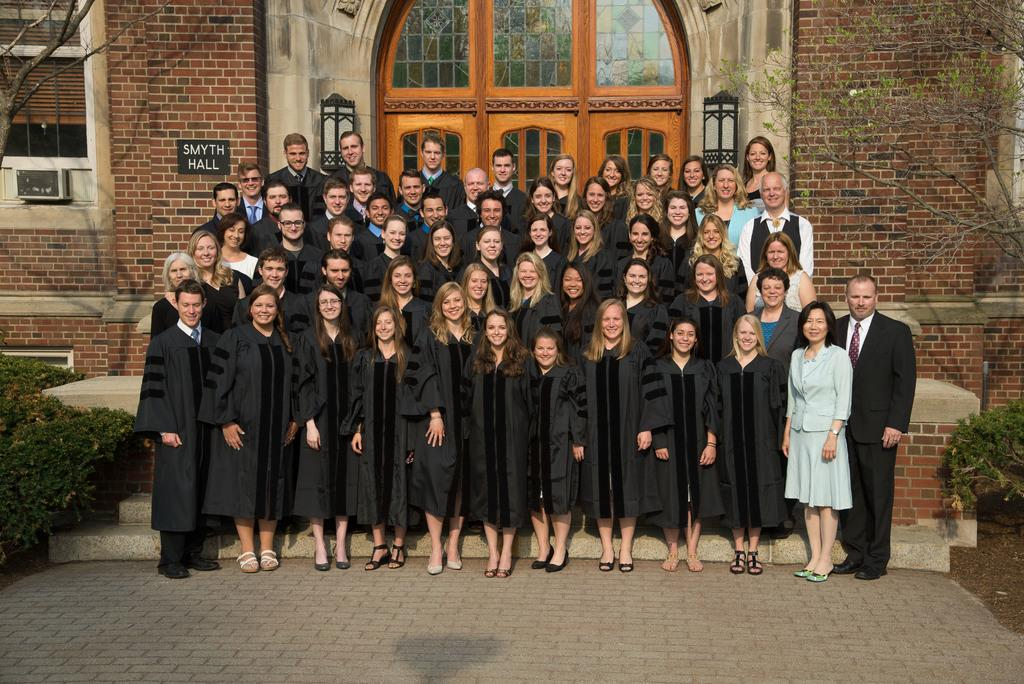What is happening with the group of people in the image? The people in the image are standing and smiling. What can be seen in the background of the image? There are trees, a building, a name board, and windows visible in the background of the image. Can you tell me which direction the bee is flying in the image? There is no bee present in the image, so it is not possible to determine the direction in which it might be flying. 